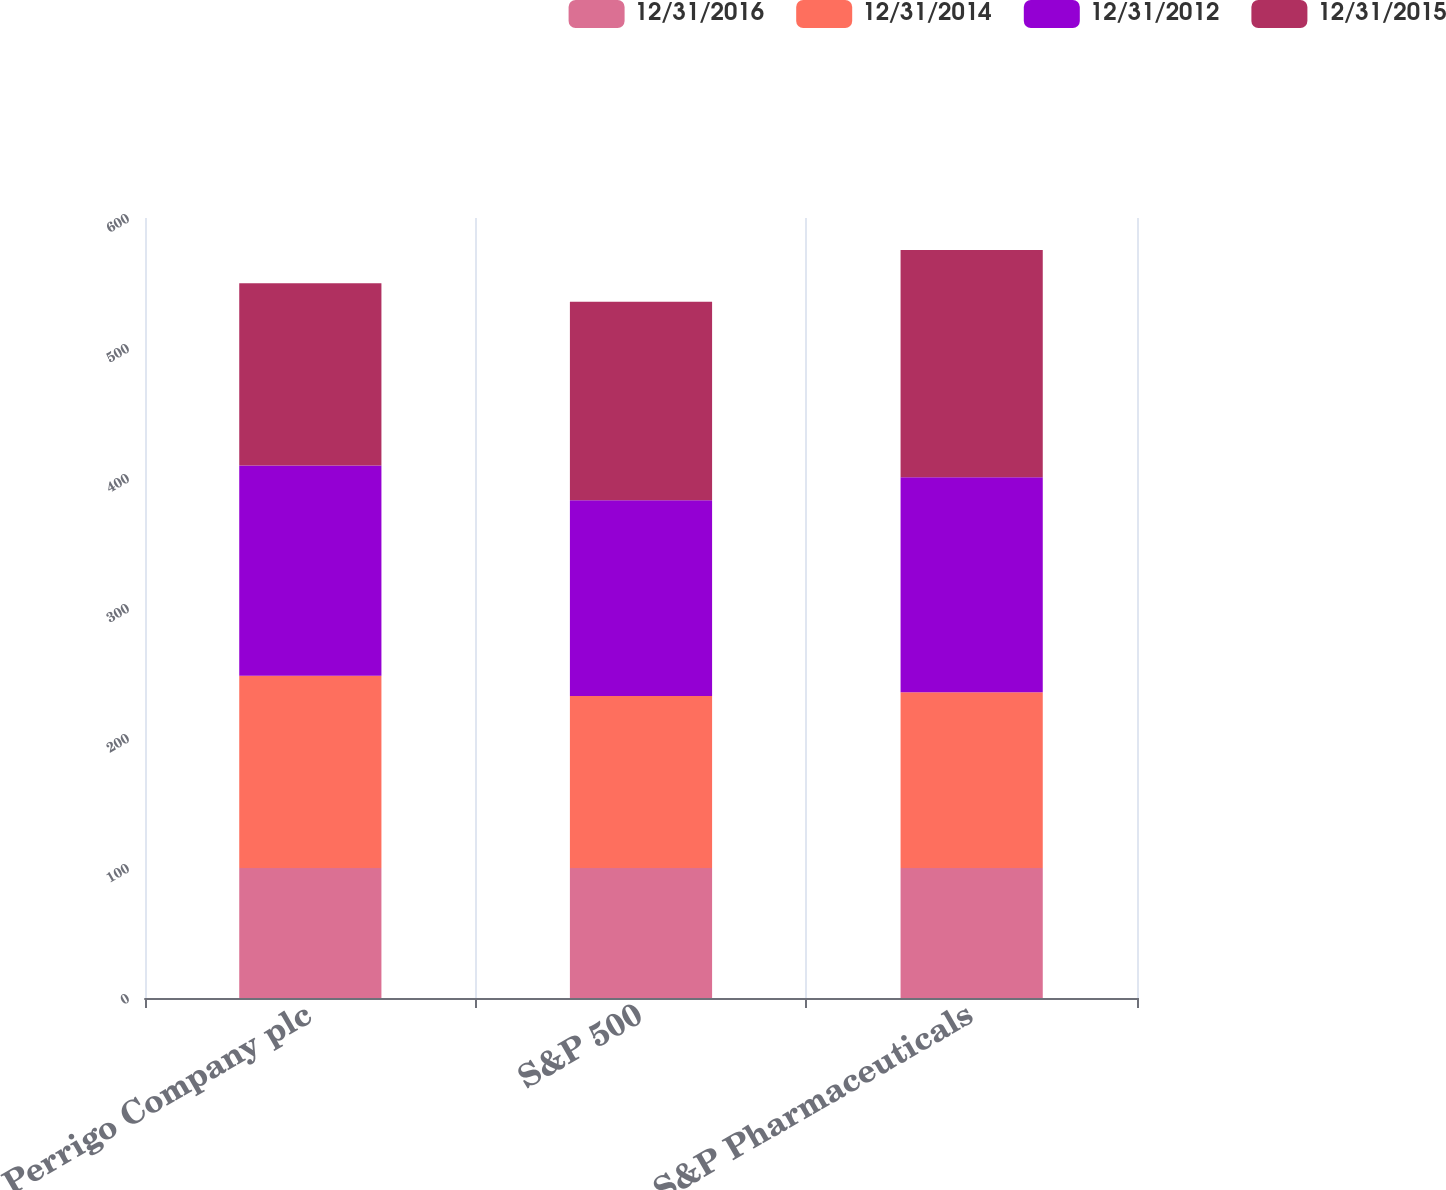Convert chart. <chart><loc_0><loc_0><loc_500><loc_500><stacked_bar_chart><ecel><fcel>Perrigo Company plc<fcel>S&P 500<fcel>S&P Pharmaceuticals<nl><fcel>12/31/2016<fcel>100<fcel>100<fcel>100<nl><fcel>12/31/2014<fcel>147.94<fcel>132.39<fcel>135.23<nl><fcel>12/31/2012<fcel>161.6<fcel>150.51<fcel>165.27<nl><fcel>12/31/2015<fcel>140.3<fcel>152.59<fcel>174.84<nl></chart> 